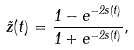<formula> <loc_0><loc_0><loc_500><loc_500>\tilde { z } ( t ) = \frac { 1 - e ^ { - 2 s ( t ) } } { 1 + e ^ { - 2 s ( t ) } } ,</formula> 